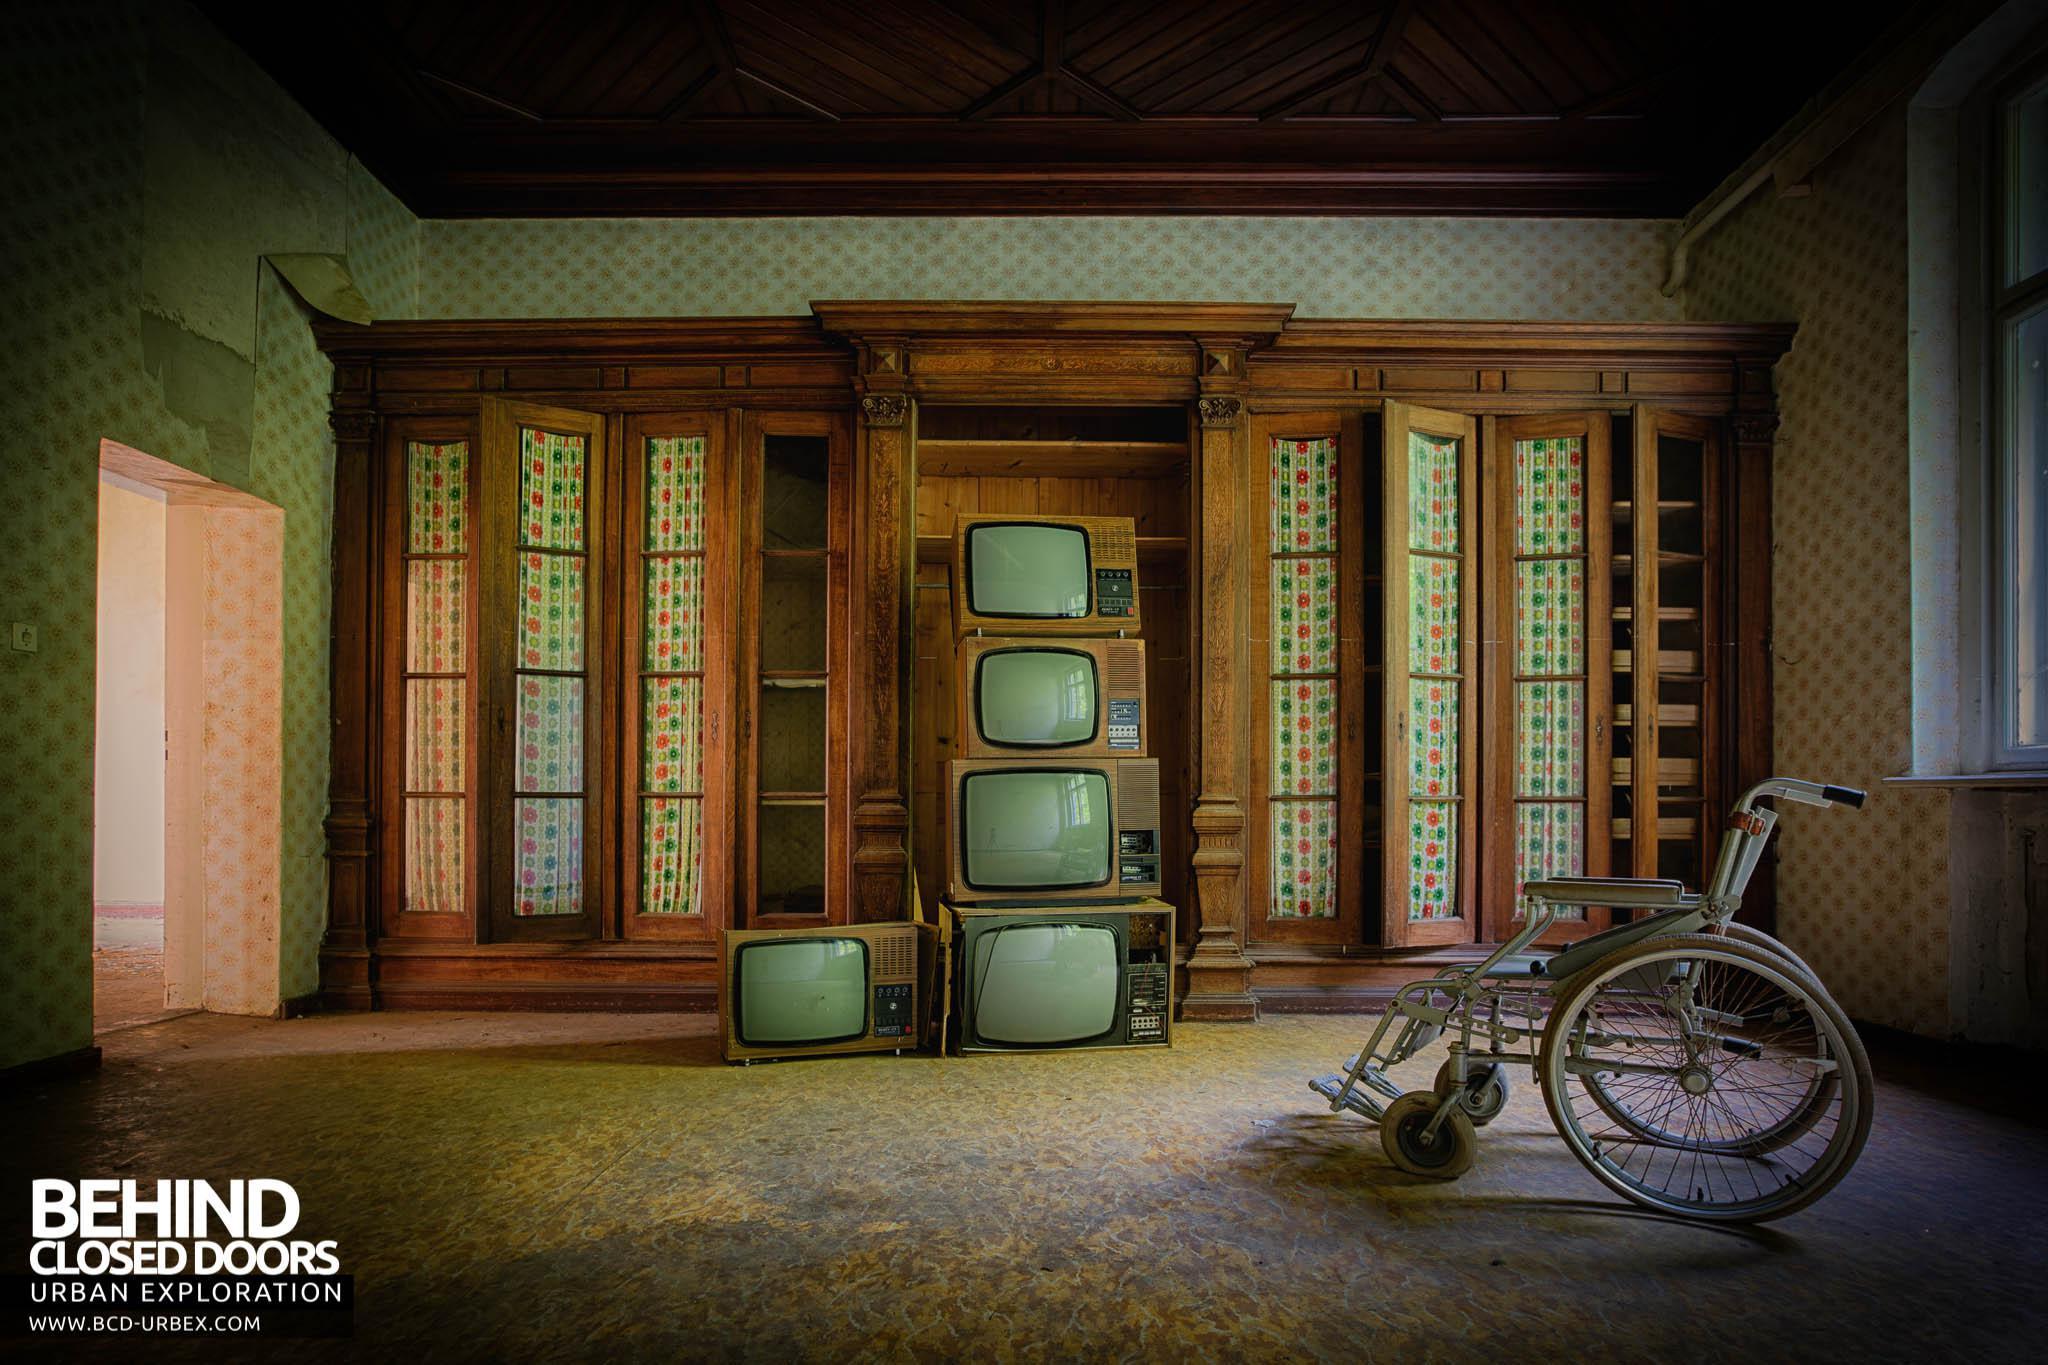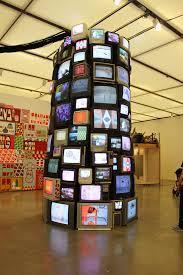The first image is the image on the left, the second image is the image on the right. For the images displayed, is the sentence "A pile of old television sits in a room with a wallpapered wall behind it." factually correct? Answer yes or no. Yes. The first image is the image on the left, the second image is the image on the right. For the images displayed, is the sentence "There is some kind of armed seat in a room containing a stack of old-fashioned TV sets." factually correct? Answer yes or no. Yes. 